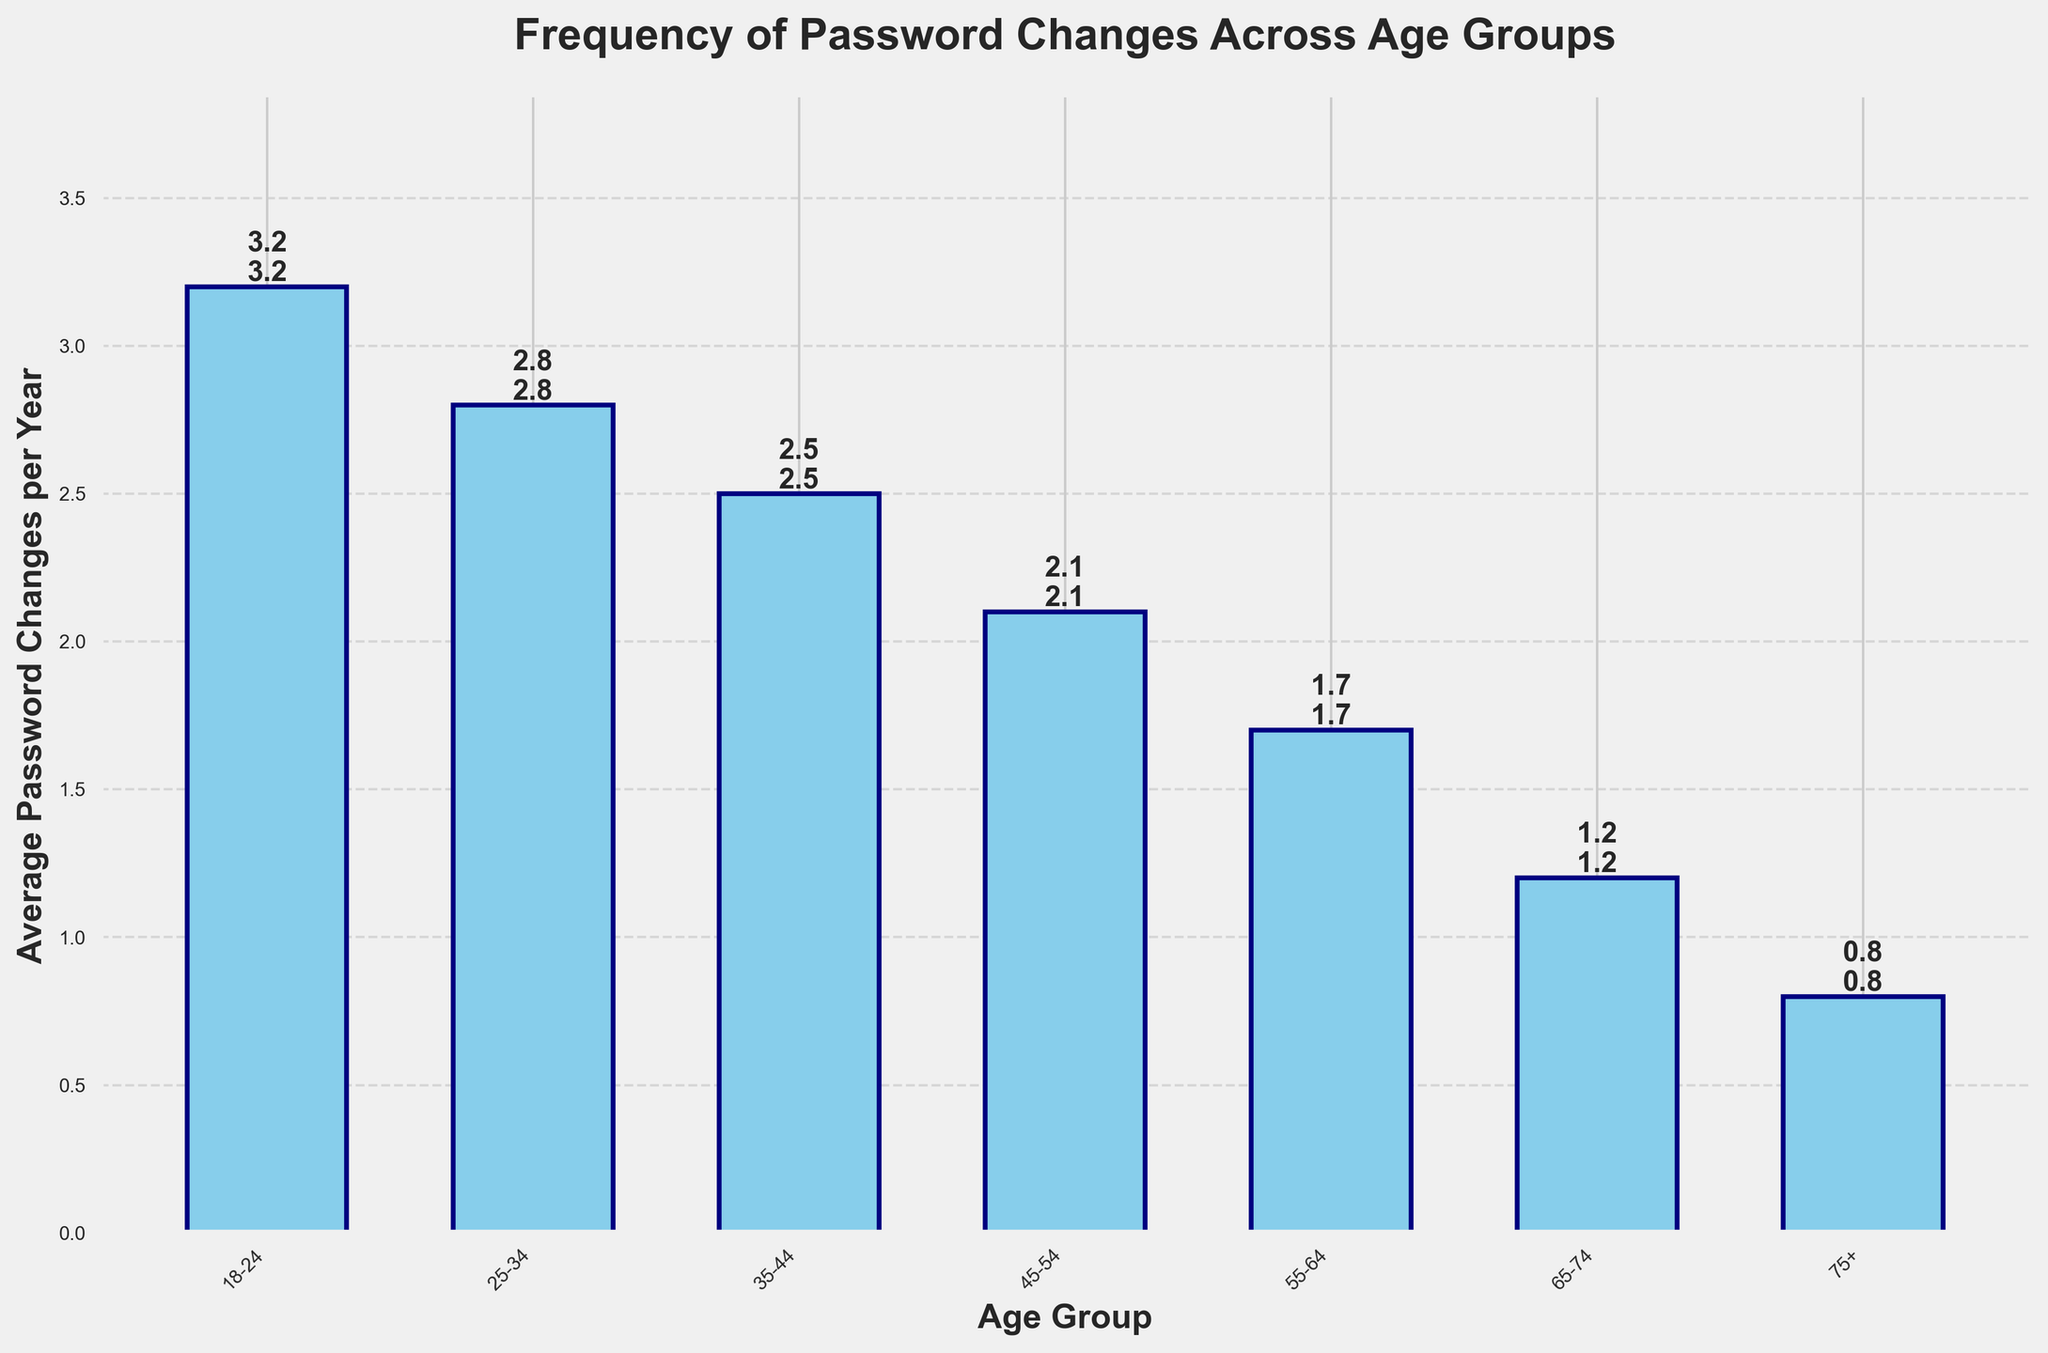What's the average number of password changes per year for people aged 55-64 compared to those aged 65-74? Look at the data bars labeled '55-64' and '65-74'. The '55-64' age group has 1.7 changes per year, and the '65-74' age group has 1.2 changes per year. Compare these two values to find that people aged 55-64 change their passwords more frequently.
Answer: 55-64 age group Which age group changes their passwords the least? Observe all the bars and find the shortest one. The bar labeled '75+' is the shortest, indicating that people aged 75 and older change their passwords the least, with only 0.8 changes per year.
Answer: 75+ How many more times per year do people aged 18-24 change their passwords compared to those aged 75+? Identify the bars corresponding to '18-24' and '75+'. The '18-24' age group has 3.2 changes per year, and the '75+' age group has 0.8 changes per year. Calculate the difference: 3.2 - 0.8 = 2.4.
Answer: 2.4 What's the general trend of password changes as age increases? Look at the height of the bars from left to right. Notice that the height decreases as the age groups get older, indicating that the frequency of password changes declines with age.
Answer: Decreases How much greater is the average number of password changes per year for the 18-24 age group compared to the 45-54 age group? Locate the bars for '18-24' and '45-54'. The values are 3.2 and 2.1, respectively. Subtract the two: 3.2 - 2.1 = 1.1.
Answer: 1.1 Which age group has the second lowest frequency of password changes per year? Examine the heights of all bars, noting the shortest bars. The second shortest after '75+' is the '65-74' group with 1.2 changes per year.
Answer: 65-74 What's the total combined average of password changes per year for the age groups below 45? Sum up the values for age groups '18-24', '25-34', and '35-44': 3.2 + 2.8 + 2.5 = 8.5.
Answer: 8.5 Among seniors (65+), how many more times do people aged 65-74 change their passwords per year than those aged 75+? Find the bars for '65-74' and '75+'. The values are 1.2 and 0.8, respectively. Subtract to find the difference: 1.2 - 0.8 = 0.4.
Answer: 0.4 